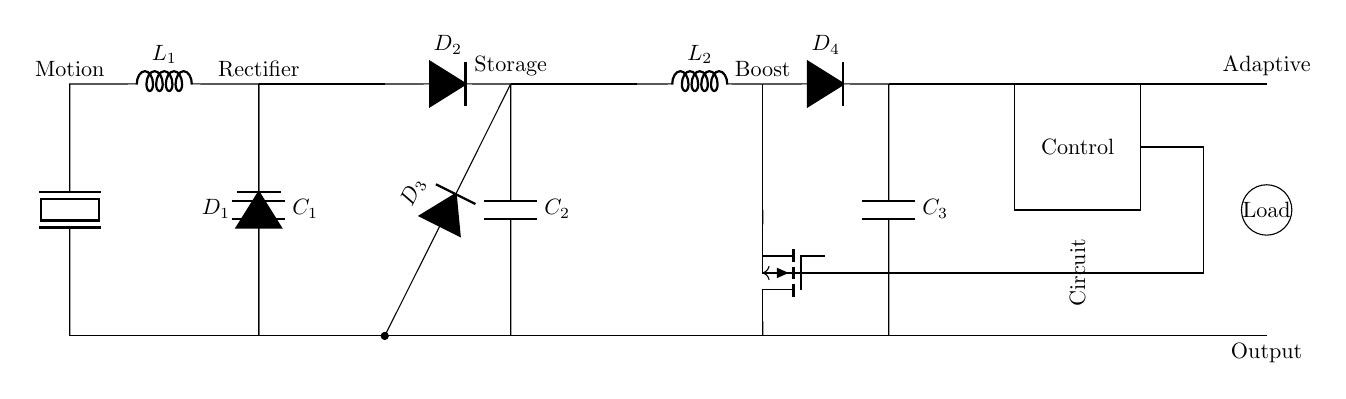What component is used to convert motion to electrical energy? The piezoelectric component is responsible for converting mechanical motion into electrical energy evidenced by its position at the start of the circuit.
Answer: Piezoelectric What is the function of D1? D1 acts as a rectifier, converting alternating current generated by the piezoelectric element into direct current for further processing and storage.
Answer: Rectifier What is the role of C3 in this circuit? C3 functions as a storage capacitor in the boost converter section, helping to smooth the output voltage by providing charge when needed.
Answer: Storage Which component stores charge from the rectified output? C1 is the component that stores the charge collected from the rectified output after conversion from the piezoelectric element.
Answer: C1 Why is there a boost converter in the circuit? The boost converter is included to increase the voltage generated from the energy harvesting section to a level sufficient for powering the load, ensuring efficient energy delivery.
Answer: To increase voltage What is the type of the control circuit? The control circuit is an adaptive controller, likely used to adjust the operation of the converter based on the energy harvested compared to the energy requirements of the load.
Answer: Adaptive What is the type of load connected at the output? The load depicted in the circuit is unspecified but is symbolized by a circle, indicating it can be any electrical device utilizing the stored energy from the circuit.
Answer: Load 